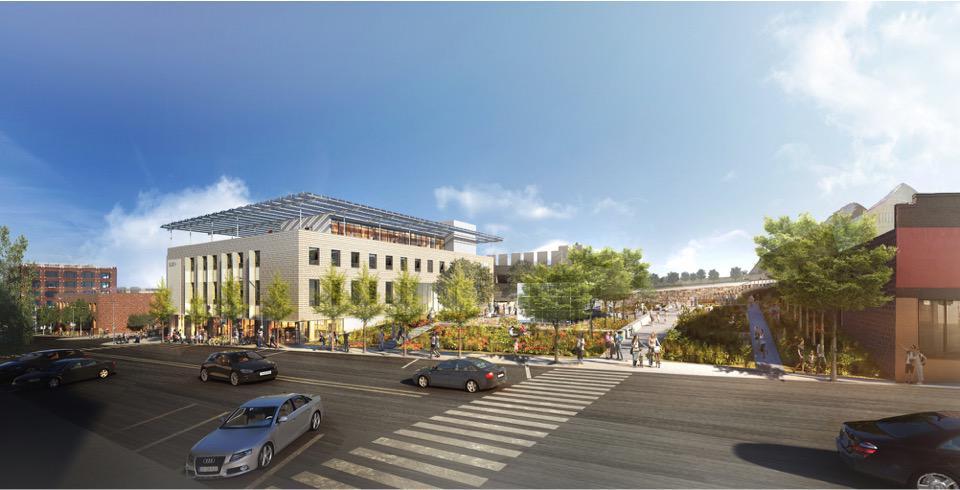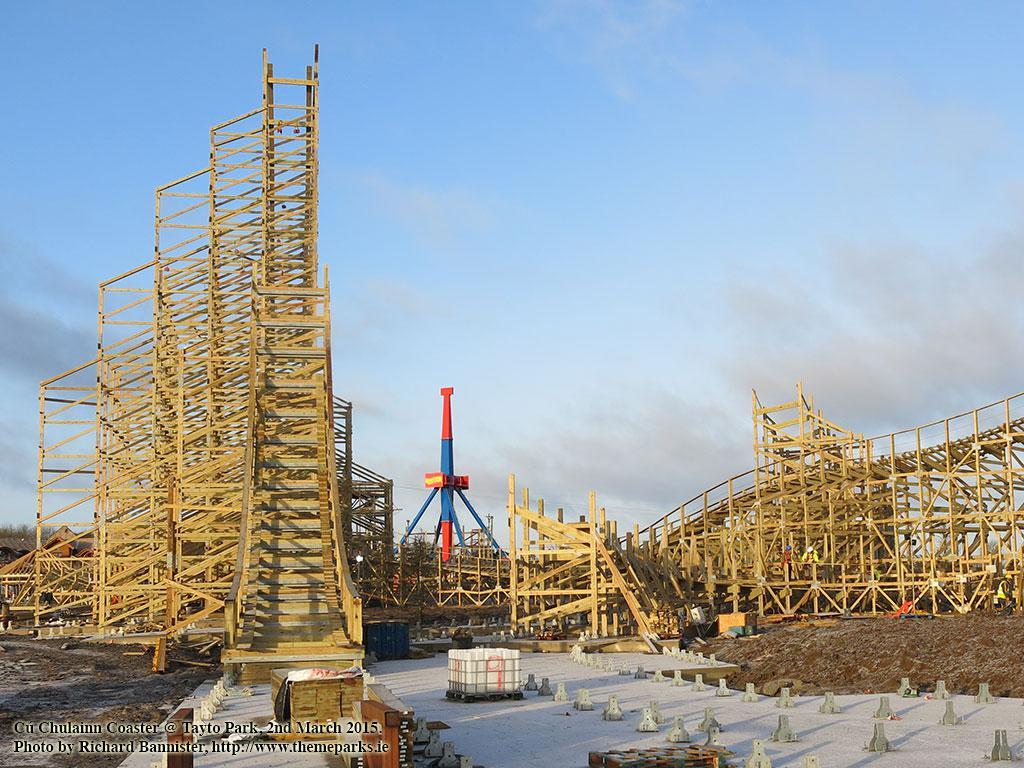The first image is the image on the left, the second image is the image on the right. Considering the images on both sides, is "In one image there are at least two cranes." valid? Answer yes or no. No. 